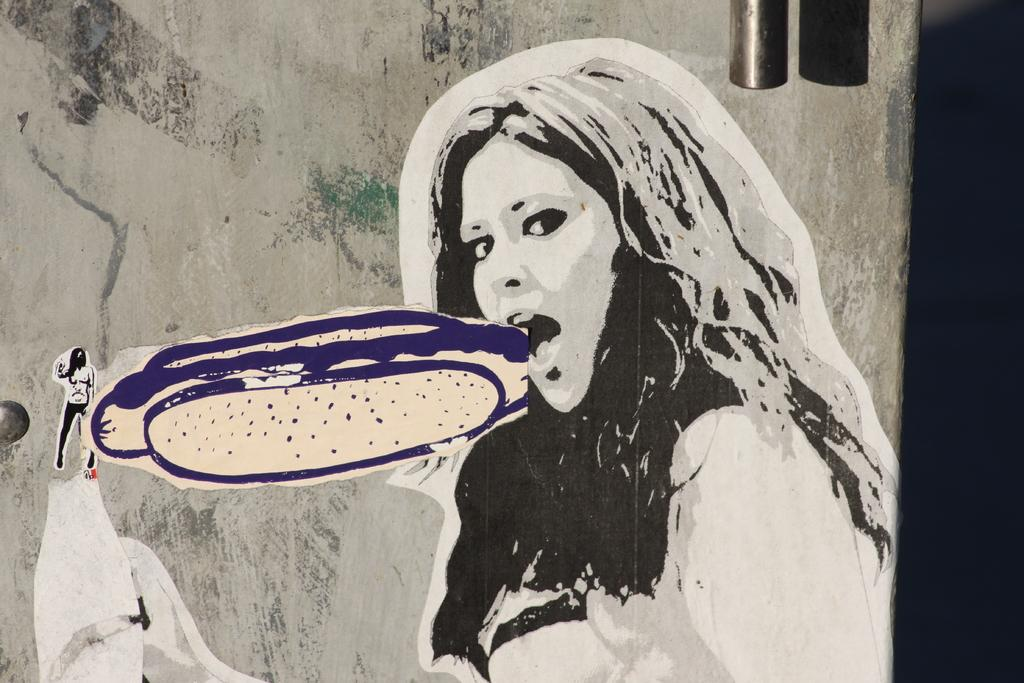What can be seen on the wall in the image? There is art on the wall in the image. Can you describe the object at the top of the image? Unfortunately, the provided facts do not give enough information to describe the object at the top of the image. How many trucks are visible in the image? There are no trucks present in the image. What type of hole can be seen in the art on the wall? There is no hole visible in the art on the wall in the image. 